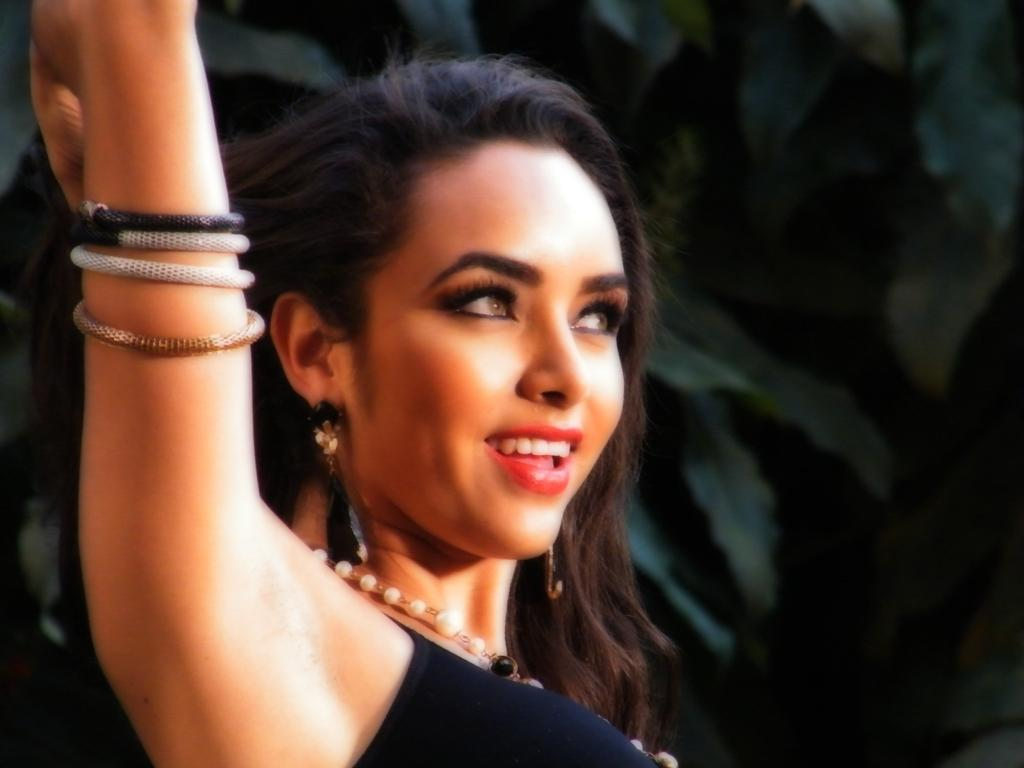Who is present in the image? There is a woman in the image. What is the woman's expression in the image? The woman is smiling in the image. What can be seen in the background of the image? There are trees in the background of the image. How many balloons are being held by the woman in the image? There are no balloons present in the image. What type of sponge can be seen in the woman's hand in the image? There is no sponge present in the woman's hand or anywhere in the image. 